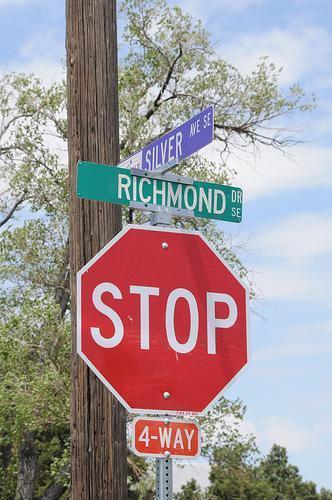How many stop signs are there?
Give a very brief answer. 1. 